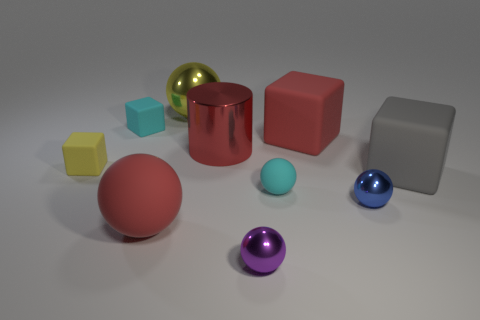Subtract all large red spheres. How many spheres are left? 4 Subtract all blue spheres. How many spheres are left? 4 Subtract all green spheres. Subtract all yellow cubes. How many spheres are left? 5 Subtract all cylinders. How many objects are left? 9 Add 8 small yellow matte things. How many small yellow matte things are left? 9 Add 4 yellow spheres. How many yellow spheres exist? 5 Subtract 1 red balls. How many objects are left? 9 Subtract all small cyan blocks. Subtract all rubber things. How many objects are left? 3 